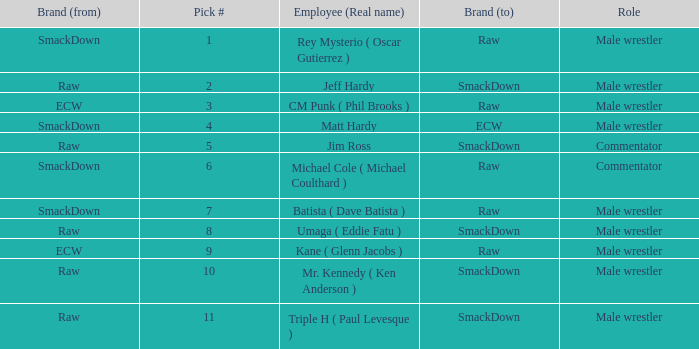What role did Pick # 10 have? Male wrestler. 